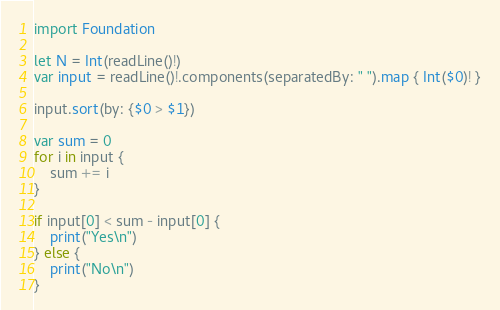Convert code to text. <code><loc_0><loc_0><loc_500><loc_500><_Swift_>import Foundation

let N = Int(readLine()!)
var input = readLine()!.components(separatedBy: " ").map { Int($0)! }

input.sort(by: {$0 > $1})

var sum = 0
for i in input {
    sum += i
}

if input[0] < sum - input[0] {
    print("Yes\n")
} else {
    print("No\n")
}
</code> 